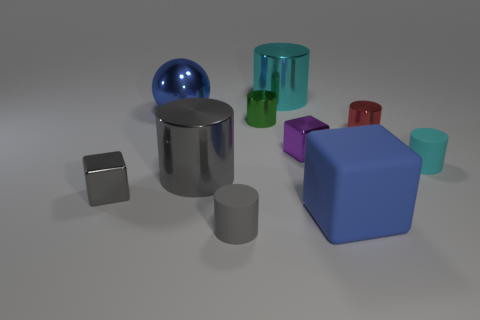The large cube that is the same material as the tiny cyan cylinder is what color?
Offer a terse response. Blue. Is the number of red objects that are in front of the blue matte object less than the number of large metal spheres?
Offer a terse response. Yes. How big is the rubber cylinder on the right side of the large metallic cylinder behind the metal block behind the cyan matte thing?
Your response must be concise. Small. Does the tiny cube that is right of the blue shiny thing have the same material as the small cyan cylinder?
Ensure brevity in your answer.  No. What material is the big thing that is the same color as the rubber cube?
Provide a succinct answer. Metal. Is there anything else that is the same shape as the large matte thing?
Offer a terse response. Yes. How many things are either tiny purple objects or large red blocks?
Provide a succinct answer. 1. What size is the purple metallic thing that is the same shape as the large rubber thing?
Make the answer very short. Small. Is there any other thing that has the same size as the matte cube?
Offer a terse response. Yes. What number of other objects are the same color as the metal sphere?
Your response must be concise. 1. 